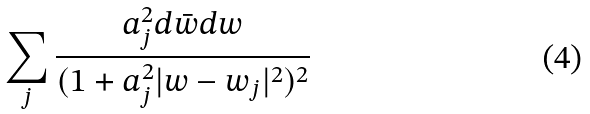<formula> <loc_0><loc_0><loc_500><loc_500>\sum _ { j } \frac { a _ { j } ^ { 2 } d \bar { w } d w } { ( 1 + a _ { j } ^ { 2 } | w - w _ { j } | ^ { 2 } ) ^ { 2 } }</formula> 